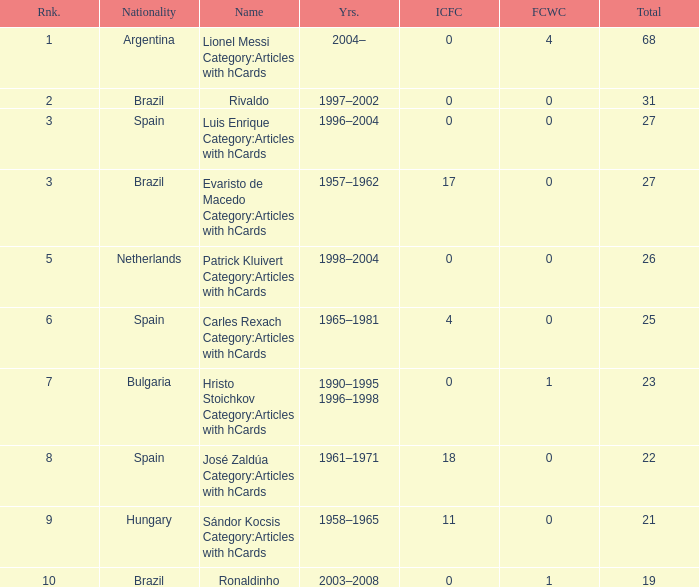What is the lowest ranking associated with a total of 23? 7.0. 